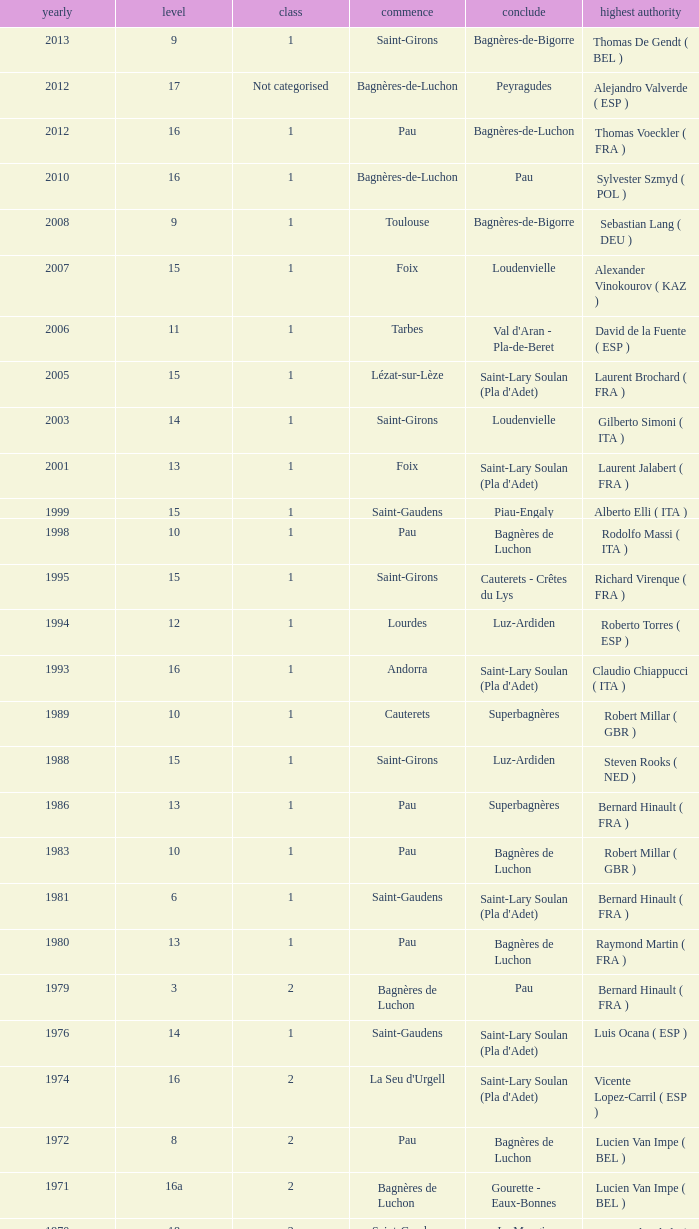What category was in 1964? 2.0. 